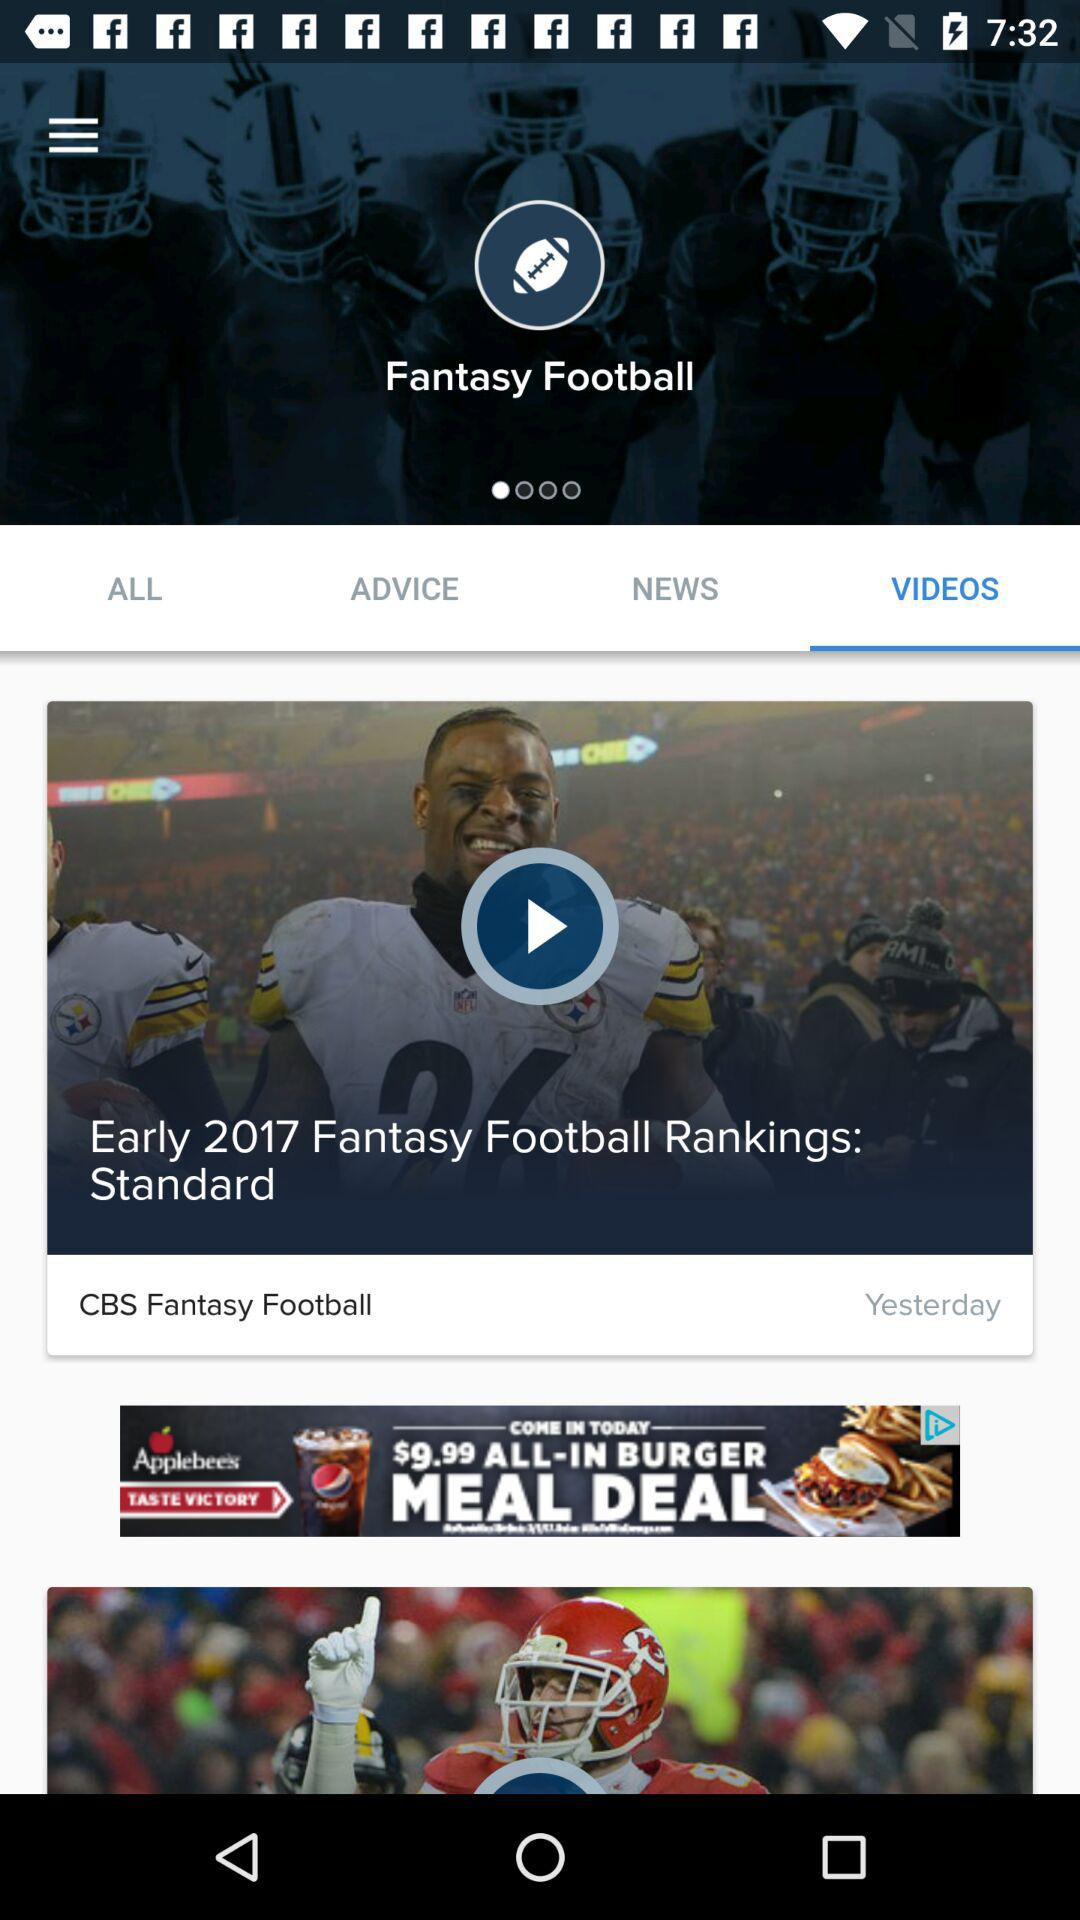Which tab is selected? The selected tab is "VIDEOS". 